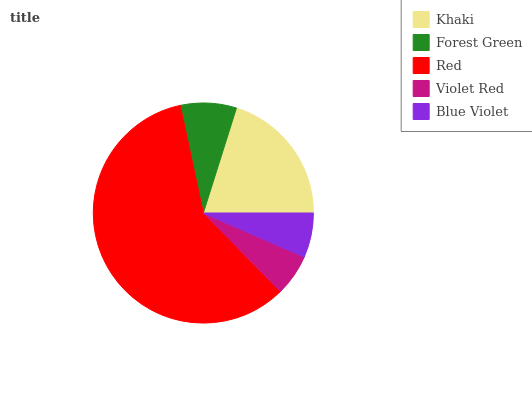Is Violet Red the minimum?
Answer yes or no. Yes. Is Red the maximum?
Answer yes or no. Yes. Is Forest Green the minimum?
Answer yes or no. No. Is Forest Green the maximum?
Answer yes or no. No. Is Khaki greater than Forest Green?
Answer yes or no. Yes. Is Forest Green less than Khaki?
Answer yes or no. Yes. Is Forest Green greater than Khaki?
Answer yes or no. No. Is Khaki less than Forest Green?
Answer yes or no. No. Is Forest Green the high median?
Answer yes or no. Yes. Is Forest Green the low median?
Answer yes or no. Yes. Is Blue Violet the high median?
Answer yes or no. No. Is Red the low median?
Answer yes or no. No. 